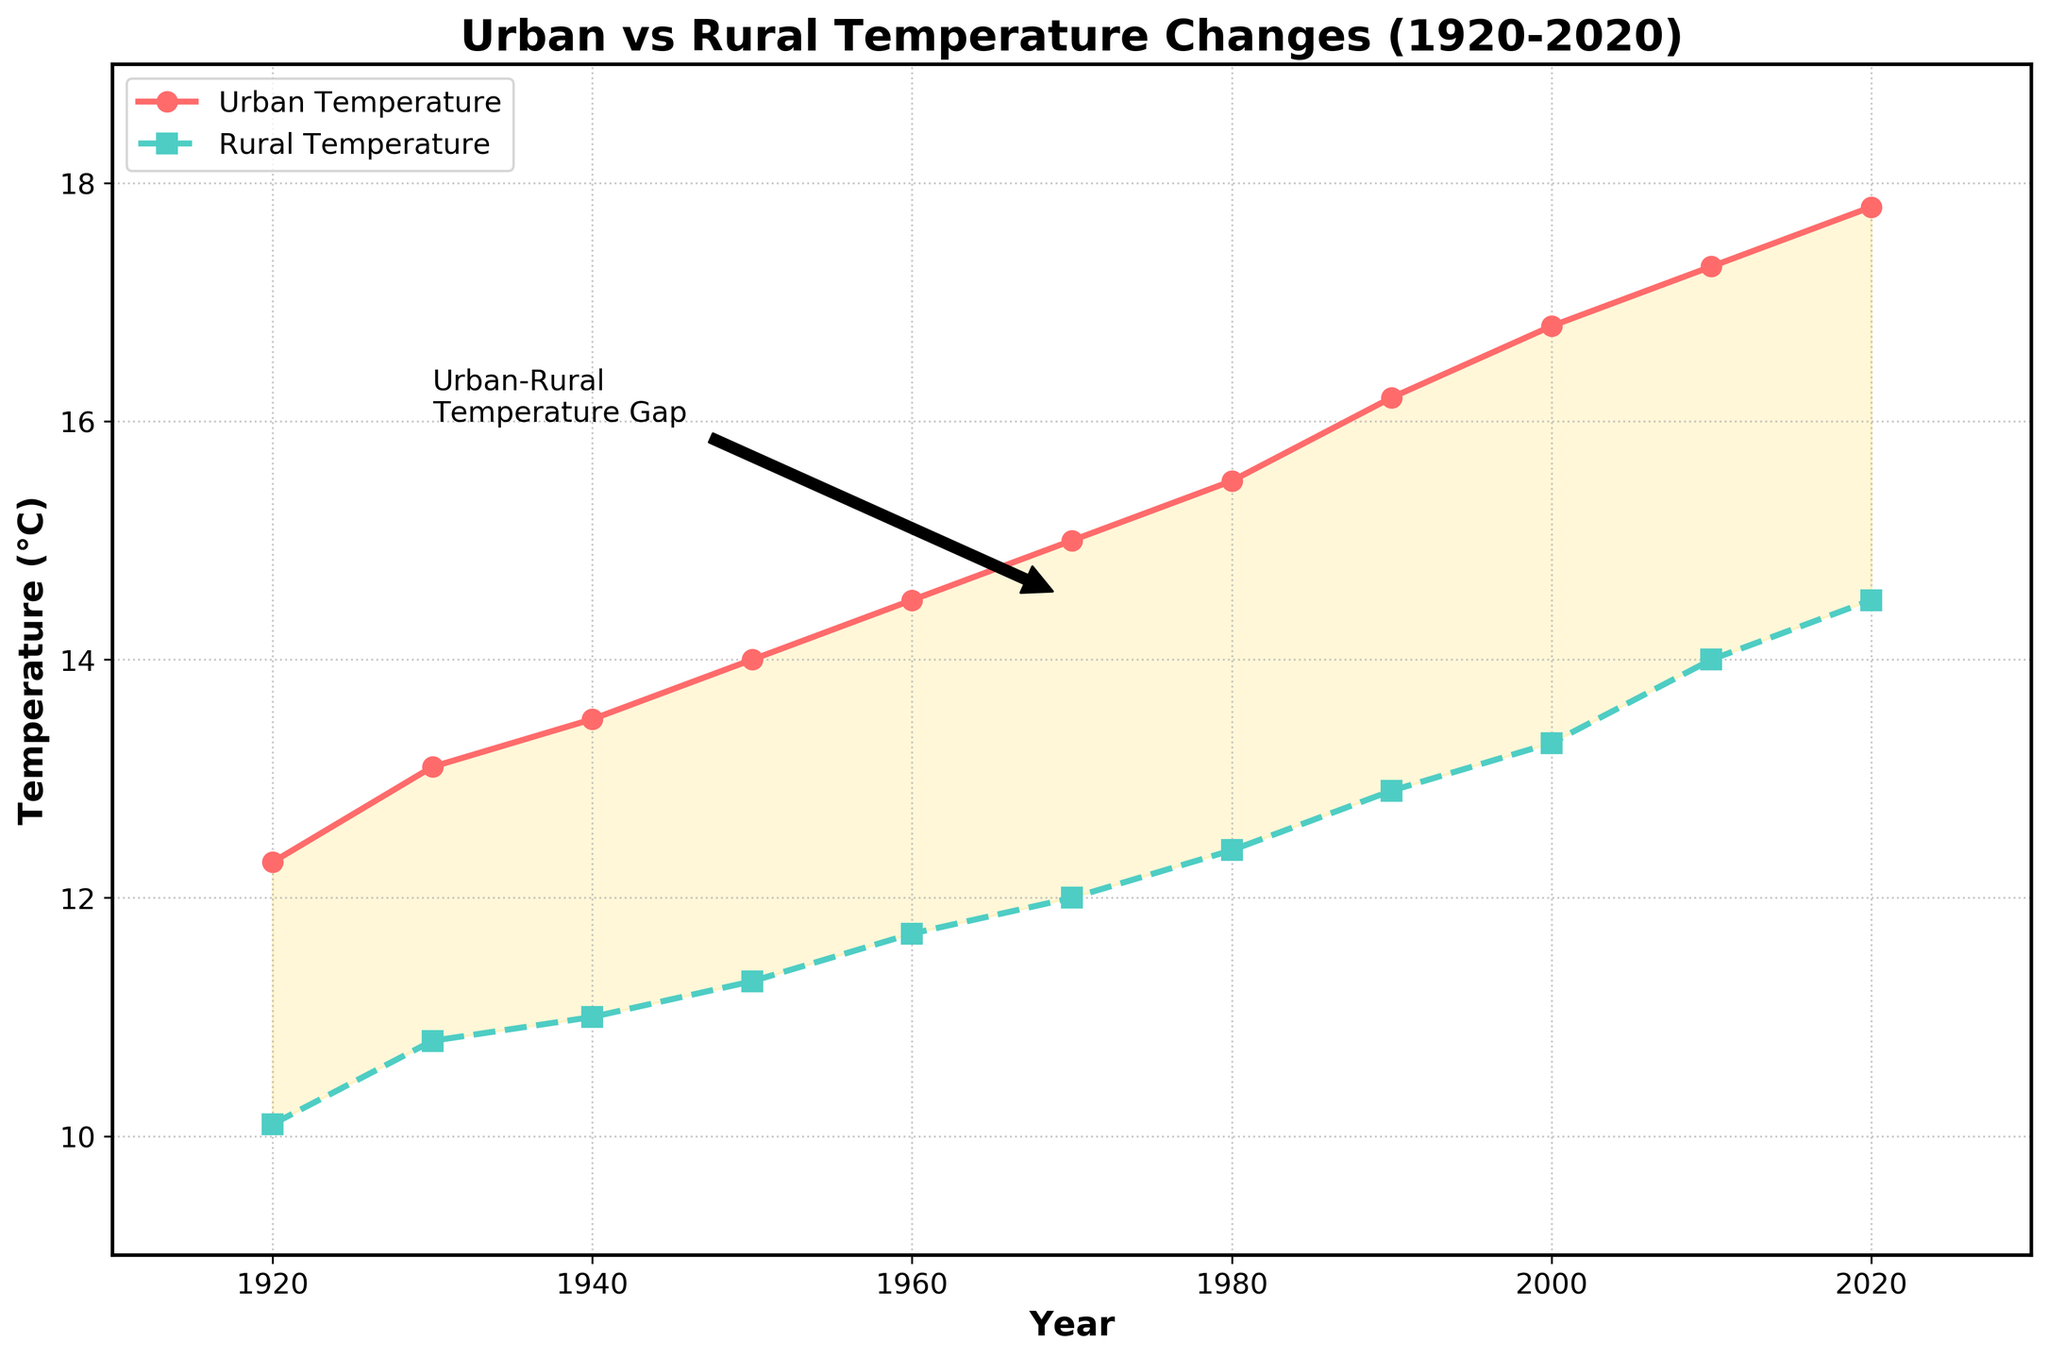what is the title of the plot? The plot's title is displayed at the top of the figure.
Answer: Urban vs Rural Temperature Changes (1920-2020) what are the two types of temperatures shown in the plot? The plot shows two types of temperatures, which are labeled directly on the figure. They are Urban Temperature and Rural Temperature.
Answer: Urban Temperature and Rural Temperature which year shows the highest urban temperature? To find the year with the highest urban temperature, look for the peak point on the urban temperature line. The highest point is around 2020.
Answer: 2020 how much was the rural temperature in 1980? Find the data point for the rural temperature on the rural temperature line for the year 1980.
Answer: 12.4°C how does the urban temperature trend compare to the rural temperature trend over the 100 years? Observe the overall direction and changes in the two lines representing the urban and rural temperatures. Both show an increasing trend, but urban temperatures rise more sharply compared to rural temperatures.
Answer: Urban temperatures increase more sharply what is the temperature gap between urban and rural areas around the year 1970? Find the temperatures for both urban and rural areas at 1970, then subtract the rural temperature from the urban temperature. The urban temperature in 1970 is 15.0°C, and the rural temperature is 12.0°C. The gap is 15.0 - 12.0.
Answer: 3.0°C which time period has the largest increase in urban temperature? Assess the slopes of the urban temperature line in different periods to identify the steepest increase. The period from 1990 to 2020 shows the largest increase.
Answer: 1990-2020 what does the yellow-shaded area between the lines represent? The yellow-shaded area is the visual difference between the urban and rural temperatures. The title of the annotation within this region gives a hint; it represents the Urban-Rural Temperature Gap.
Answer: Urban-Rural Temperature Gap are the variations in rural temperatures larger in earlier or later decades? Analyze the increasing or decreasing trend of data points (displayed as error bars) for Rural Temperature Deviation over the years. It starts lower in earlier decades and increases in later decades.
Answer: Larger in later decades compare the average urban temperature of the first 50 years to the last 50 years. Calculate the average of urban temperatures from 1920 to 1970 and 1970 to 2020. First 50 years: (12.3 + 13.1 + 13.5 + 14.0 + 14.5) / 5 = 13.48°C. Last 50 years: (15.0 + 15.5 + 16.2 + 16.8 + 17.3 + 17.8) / 6 = 16.1°C. Compare both averages.
Answer: 13.48°C for first 50 years, 16.1°C for last 50 years 